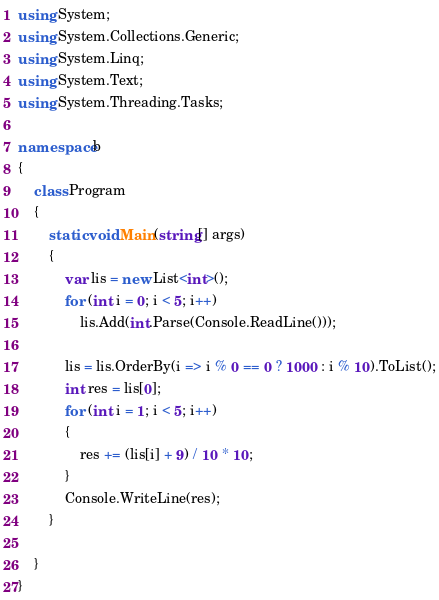<code> <loc_0><loc_0><loc_500><loc_500><_C#_>using System;
using System.Collections.Generic;
using System.Linq;
using System.Text;
using System.Threading.Tasks;

namespace b
{
    class Program
    {
        static void Main(string[] args)
        {
            var lis = new List<int>();
            for (int i = 0; i < 5; i++)
                lis.Add(int.Parse(Console.ReadLine()));

            lis = lis.OrderBy(i => i % 0 == 0 ? 1000 : i % 10).ToList();
            int res = lis[0];
            for (int i = 1; i < 5; i++)
            {
                res += (lis[i] + 9) / 10 * 10;
            }
            Console.WriteLine(res);
        }

    }
}
</code> 